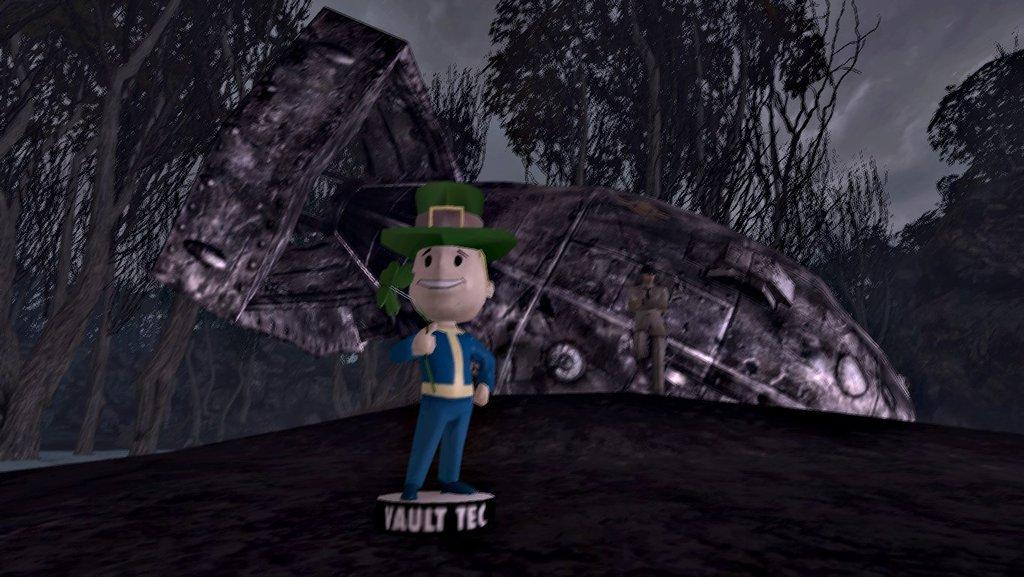What is on the ground in the image? There are toys on the ground in the image. What can be seen in the background of the image? There are objects and trees visible in the background of the image. What part of the natural environment is visible in the image? The sky is visible in the background of the image. What type of good-bye is being said in the image? There is no indication of anyone saying good-bye in the image. How many socks are visible in the image? There are no socks visible in the image. 